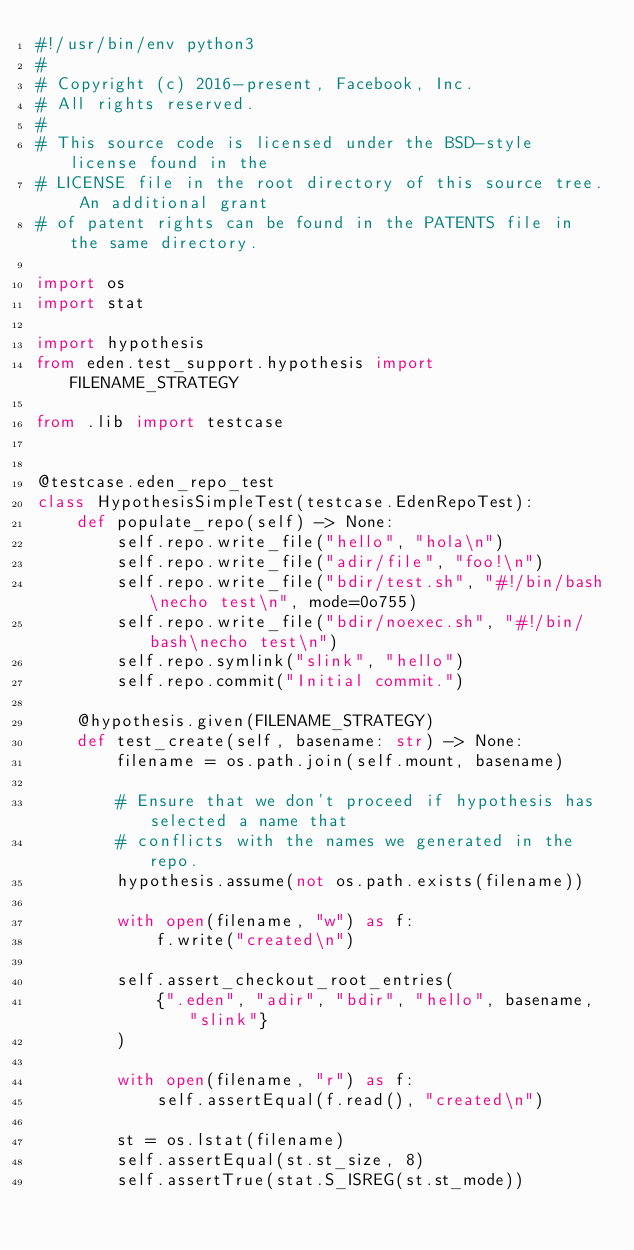Convert code to text. <code><loc_0><loc_0><loc_500><loc_500><_Python_>#!/usr/bin/env python3
#
# Copyright (c) 2016-present, Facebook, Inc.
# All rights reserved.
#
# This source code is licensed under the BSD-style license found in the
# LICENSE file in the root directory of this source tree. An additional grant
# of patent rights can be found in the PATENTS file in the same directory.

import os
import stat

import hypothesis
from eden.test_support.hypothesis import FILENAME_STRATEGY

from .lib import testcase


@testcase.eden_repo_test
class HypothesisSimpleTest(testcase.EdenRepoTest):
    def populate_repo(self) -> None:
        self.repo.write_file("hello", "hola\n")
        self.repo.write_file("adir/file", "foo!\n")
        self.repo.write_file("bdir/test.sh", "#!/bin/bash\necho test\n", mode=0o755)
        self.repo.write_file("bdir/noexec.sh", "#!/bin/bash\necho test\n")
        self.repo.symlink("slink", "hello")
        self.repo.commit("Initial commit.")

    @hypothesis.given(FILENAME_STRATEGY)
    def test_create(self, basename: str) -> None:
        filename = os.path.join(self.mount, basename)

        # Ensure that we don't proceed if hypothesis has selected a name that
        # conflicts with the names we generated in the repo.
        hypothesis.assume(not os.path.exists(filename))

        with open(filename, "w") as f:
            f.write("created\n")

        self.assert_checkout_root_entries(
            {".eden", "adir", "bdir", "hello", basename, "slink"}
        )

        with open(filename, "r") as f:
            self.assertEqual(f.read(), "created\n")

        st = os.lstat(filename)
        self.assertEqual(st.st_size, 8)
        self.assertTrue(stat.S_ISREG(st.st_mode))
</code> 